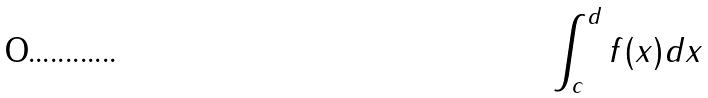<formula> <loc_0><loc_0><loc_500><loc_500>\int _ { c } ^ { d } f ( x ) d x</formula> 